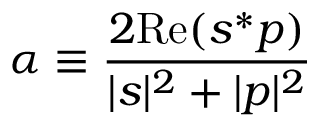Convert formula to latex. <formula><loc_0><loc_0><loc_500><loc_500>\alpha \equiv \frac { 2 R e ( s ^ { * } p ) } { | s | ^ { 2 } + | p | ^ { 2 } }</formula> 